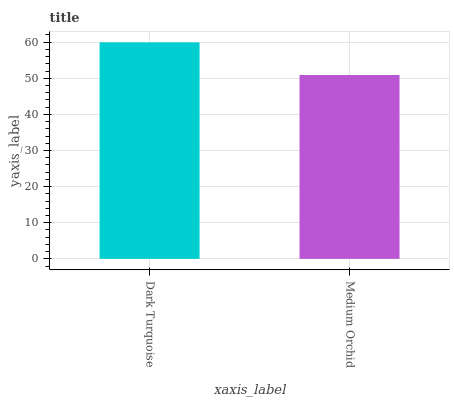Is Medium Orchid the minimum?
Answer yes or no. Yes. Is Dark Turquoise the maximum?
Answer yes or no. Yes. Is Medium Orchid the maximum?
Answer yes or no. No. Is Dark Turquoise greater than Medium Orchid?
Answer yes or no. Yes. Is Medium Orchid less than Dark Turquoise?
Answer yes or no. Yes. Is Medium Orchid greater than Dark Turquoise?
Answer yes or no. No. Is Dark Turquoise less than Medium Orchid?
Answer yes or no. No. Is Dark Turquoise the high median?
Answer yes or no. Yes. Is Medium Orchid the low median?
Answer yes or no. Yes. Is Medium Orchid the high median?
Answer yes or no. No. Is Dark Turquoise the low median?
Answer yes or no. No. 